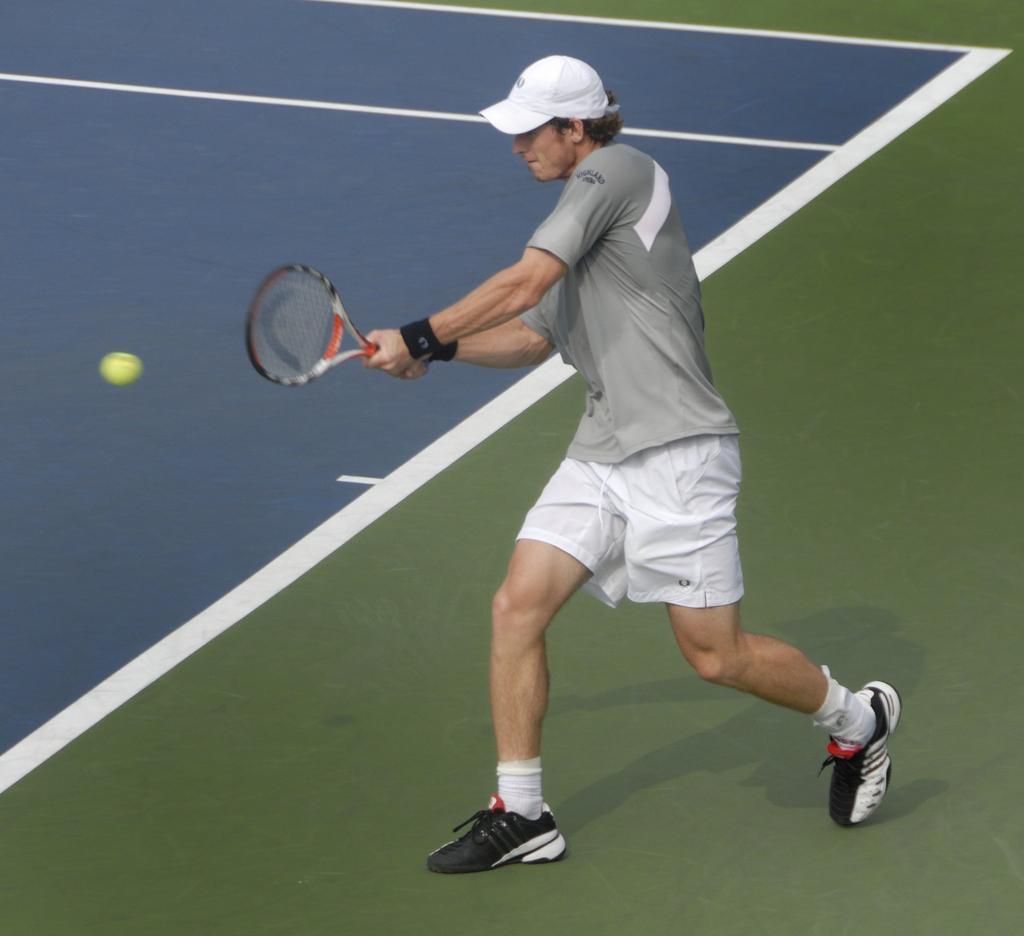In one or two sentences, can you explain what this image depicts? In this image, we can see a person wearing a cap and holding a tennis racket with his hands. There is a ball on the left side of the image. 